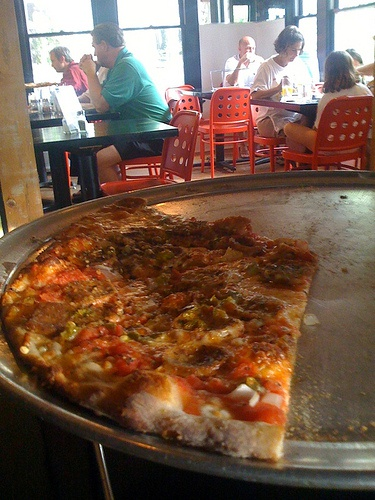Describe the objects in this image and their specific colors. I can see pizza in gray, maroon, brown, and black tones, people in gray, teal, and darkgray tones, dining table in gray, black, teal, and ivory tones, chair in gray, maroon, and brown tones, and people in gray, white, darkgray, brown, and lightpink tones in this image. 